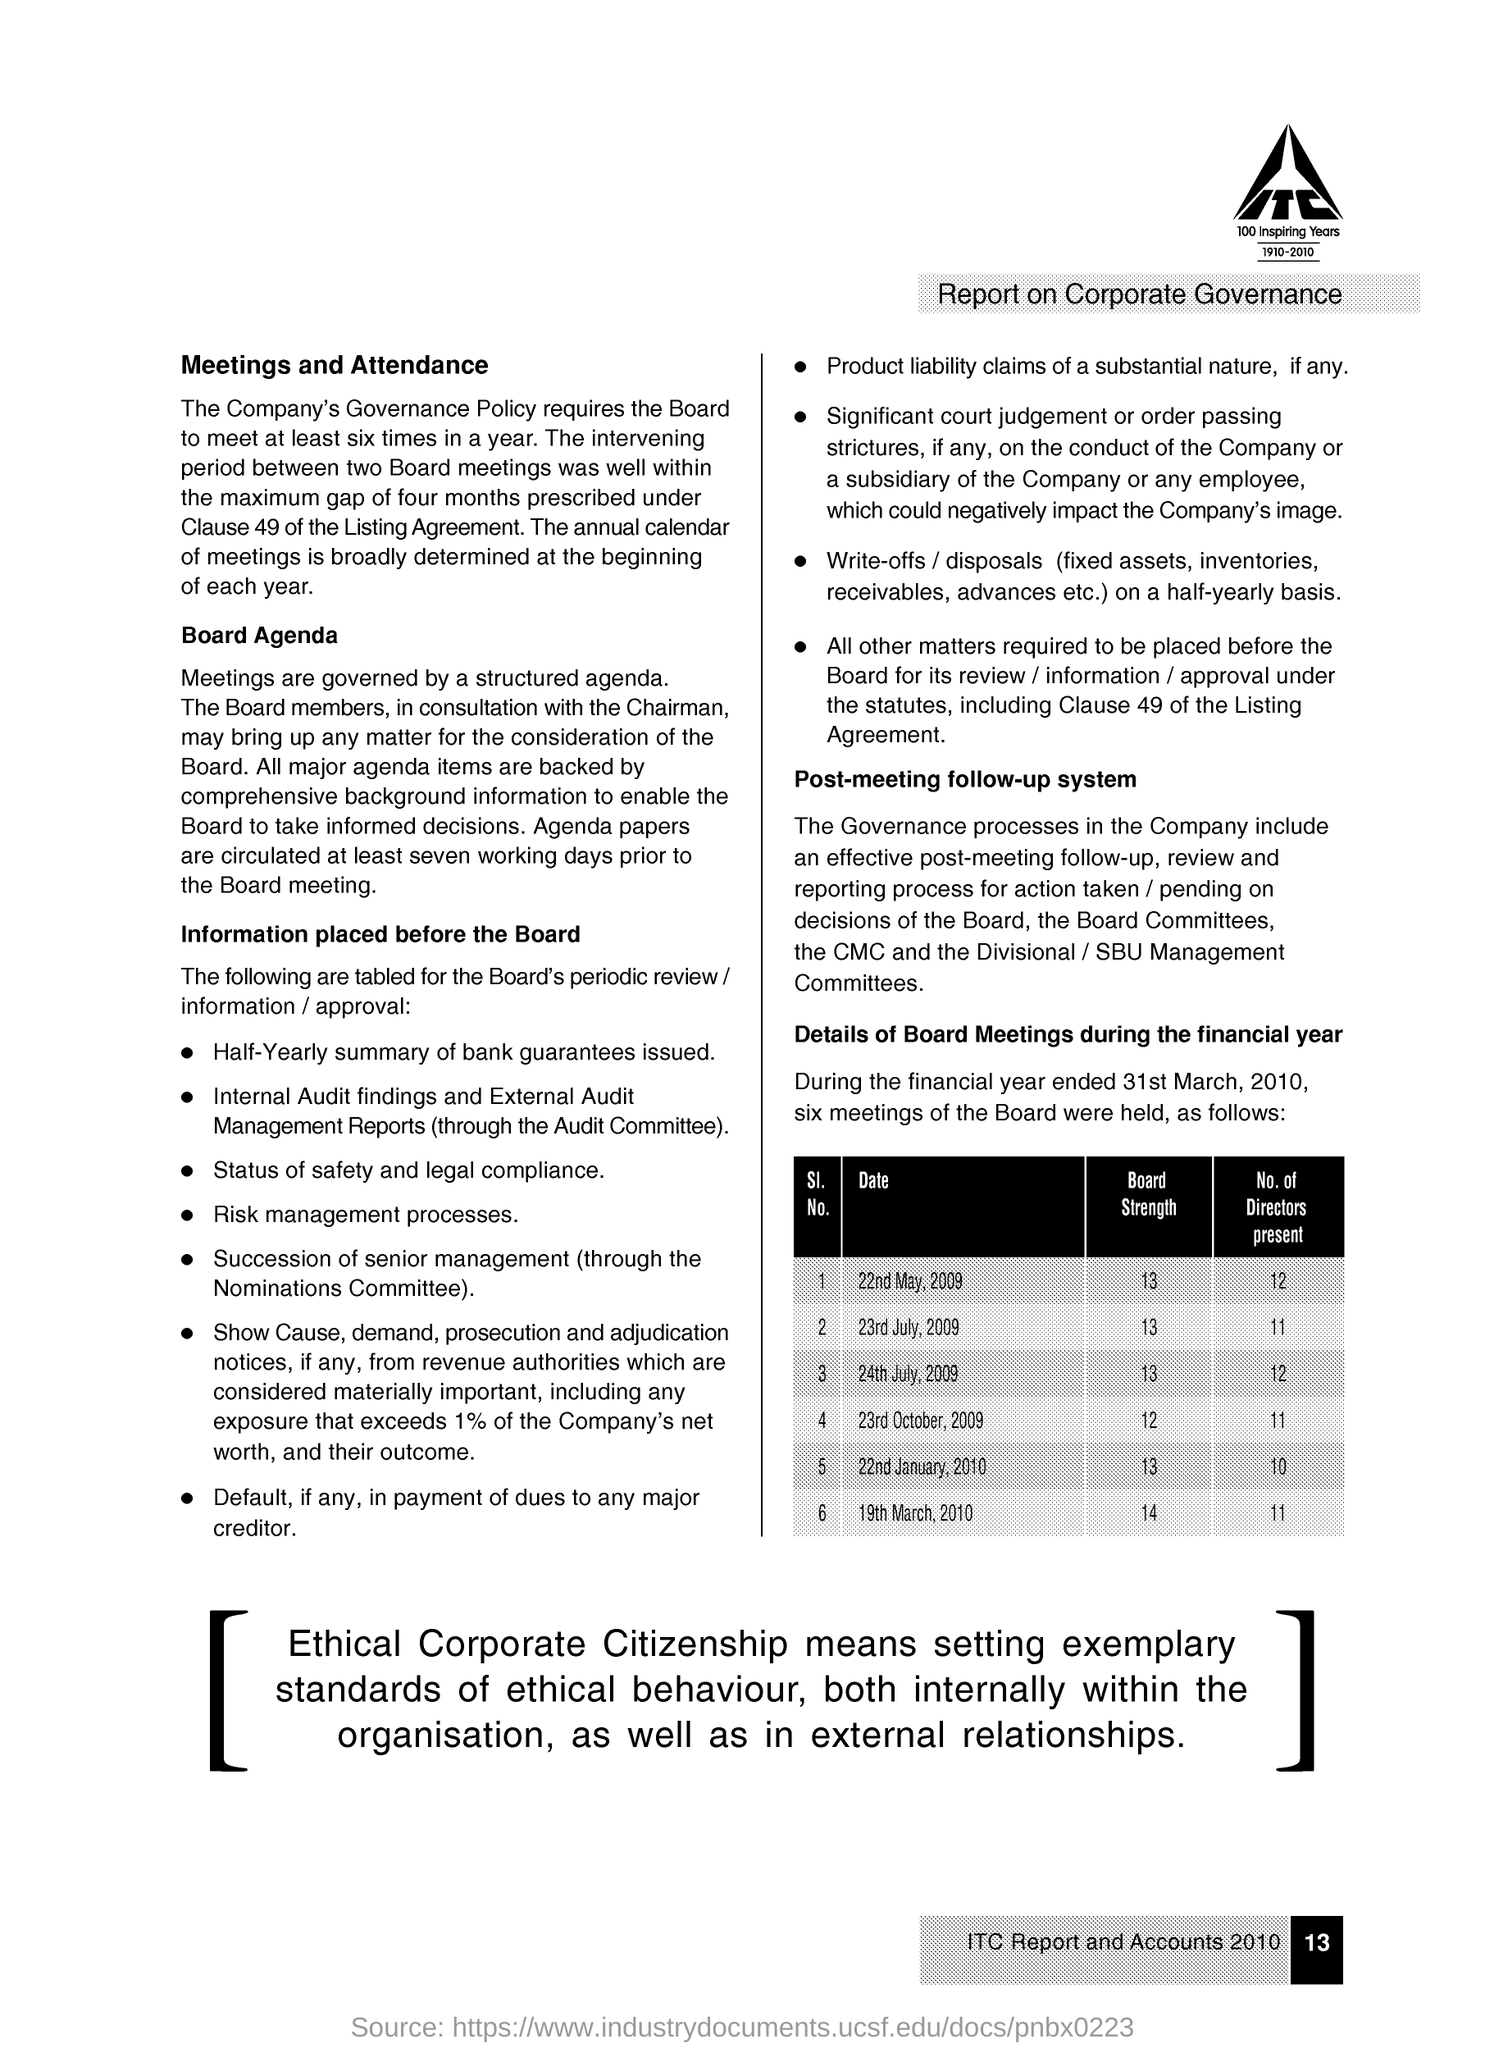What is the Page Number?
Keep it short and to the point. 13. What is the number of directors present on 22nd May 2009?
Offer a very short reply. 12. What is the number of directors present on 22nd January 2010?
Your answer should be very brief. 10. What is the minimum number of directors present?
Your response must be concise. 10. 